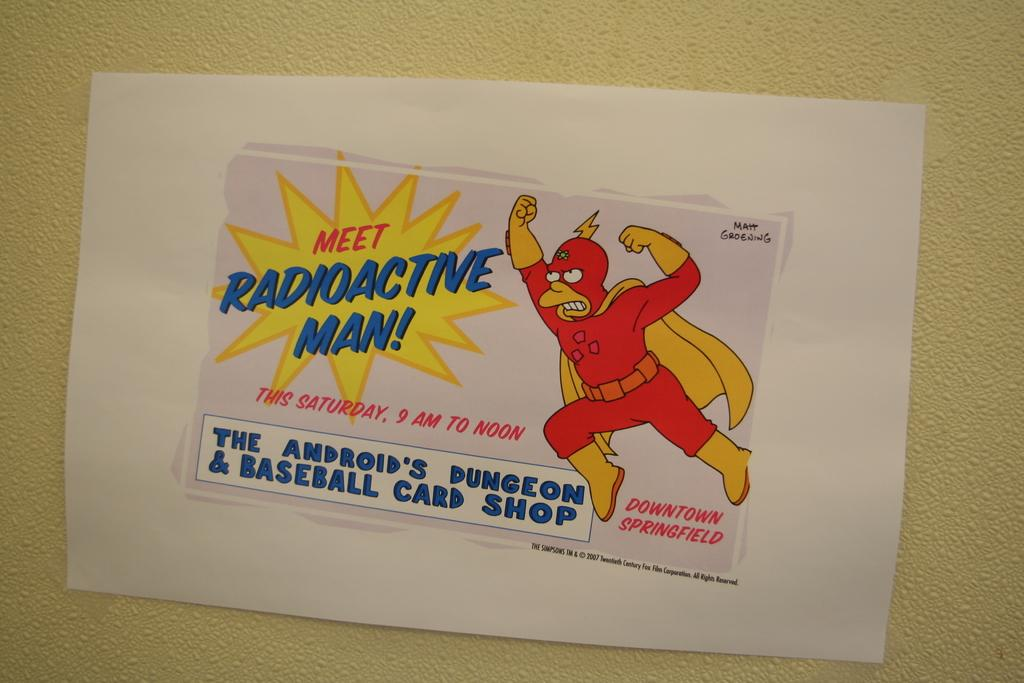What is on the wall in the image? There is a paper on the wall in the image. What can be found on the paper? The paper contains text and an image. Can you hear a whistle in the image? There is no whistle present in the image; it is a paper on the wall with text and an image. How does the paper care for the image? The paper does not care for the image; it simply contains the image as part of its content. 